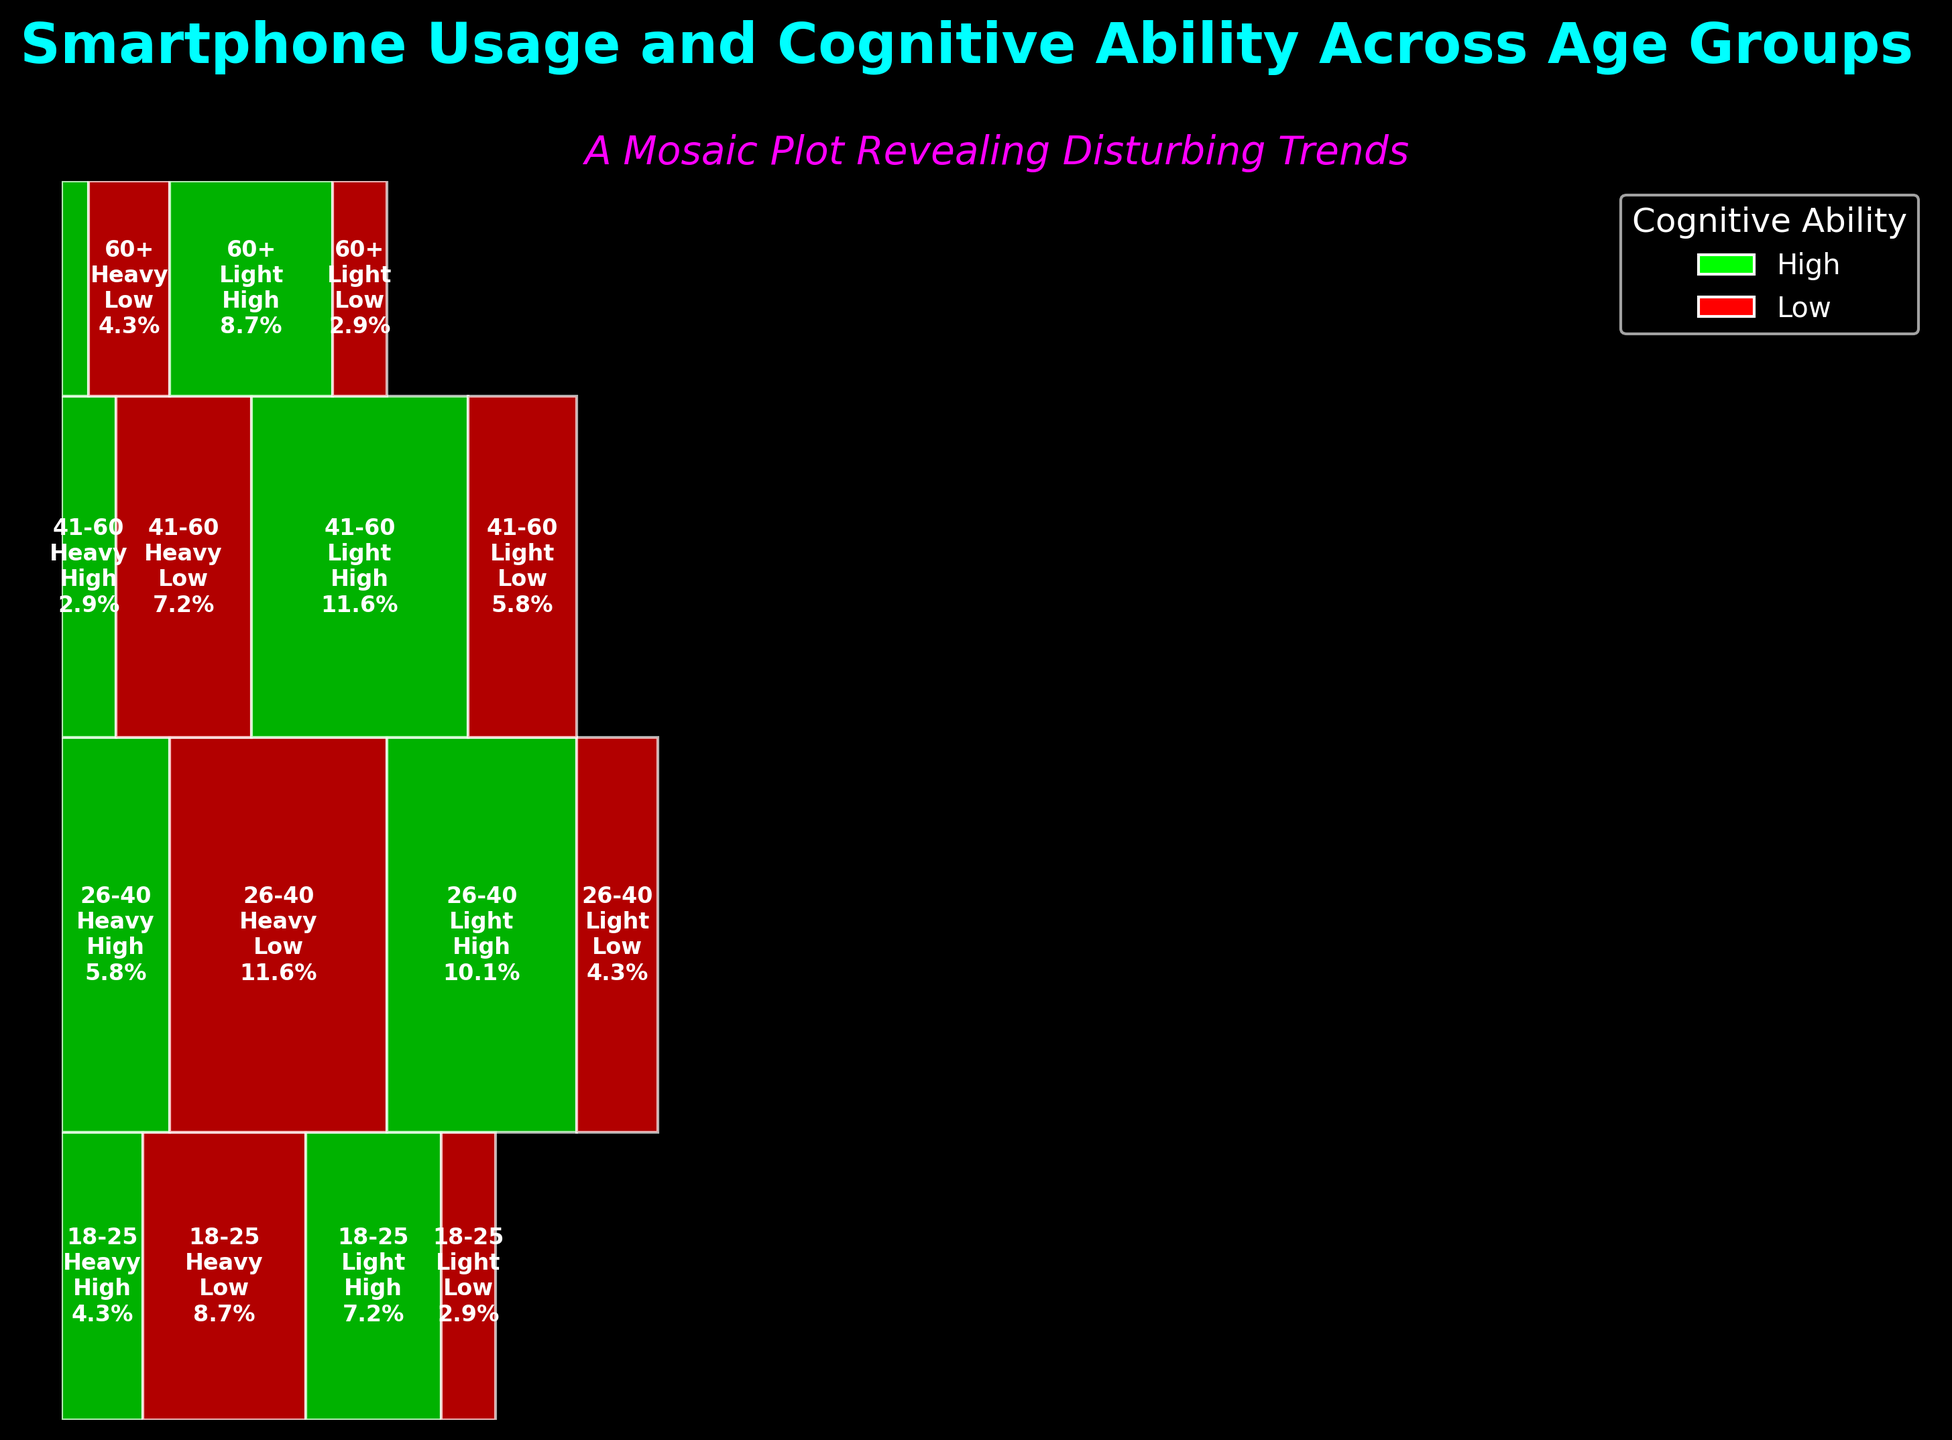What's the title of the plot? The title of the plot is displayed at the top center of the figure and helps identify the main topic or focus.
Answer: Smartphone Usage and Cognitive Ability Across Age Groups Which cognitive ability level is represented by the color red? The legend indicates that the color red is associated with 'Low' cognitive ability.
Answer: Low Which age group has the highest proportion of light smartphone usage with high cognitive ability? We need to look for the age group that has the largest rectangle width for "Light" smartphone usage colored in green (high cognitive ability). The 41-60 age group has the widest rectangle in light usage with high cognitive ability.
Answer: 41-60 For the 26-40 age group, how does the proportion of heavy users with low cognitive ability compare to light users with high cognitive ability? For the 26-40 age group, the width of the rectangles for 'Heavy' usage with 'Low' ability is larger compared to 'Light' usage with 'High' ability. This shows a greater proportion of heavy users with low ability.
Answer: Greater proportion What is the total proportion of light smartphone users with high cognitive ability across all age groups? Sum the widths of all the green rectangles (high ability) under the 'Light' usage category across all age groups. This includes 18-25, 26-40, 41-60, and 60+.
Answer: (250 + 350 + 400 + 300) / 3600 = 36.1% Compare the cognitive ability of light smartphone users in the 60+ age group to heavy smartphone users in the same age group. Which group has a higher proportion of high cognitive ability? For the 60+ age group, the width of the green rectangle (high cognitive ability) for 'Light' usage is larger than the width for 'Heavy' usage. This indicates a higher proportion of light smartphone users with high cognitive ability.
Answer: Light users have a higher proportion How does the proportion of heavy users with low cognitive ability in the 18-25 group compare to the proportion of heavy users with high cognitive ability in the same group? Compare the width of the red rectangle (low ability) to the green rectangle (high ability) under 'Heavy' usage for the 18-25 age group. The red rectangle is much larger, indicating a higher proportion of low ability among heavy users.
Answer: Higher proportion of low ability What proportion of total smartphone users has low cognitive ability in the 41-60 age group? Sum the widths of both red rectangles (low ability) for the 'Heavy' and 'Light' usage in the 41-60 age group and compare it to the total user base.
Answer: (250 + 200) / 3600 = 12.5% Which age group exhibits the lowest proportion of heavy smartphone usage with low cognitive ability? Identify the columns with the red rectangle under 'Heavy' usage and find the age group with the smallest width. The 60+ age group has the smallest width indicating the lowest proportion.
Answer: 60+ 